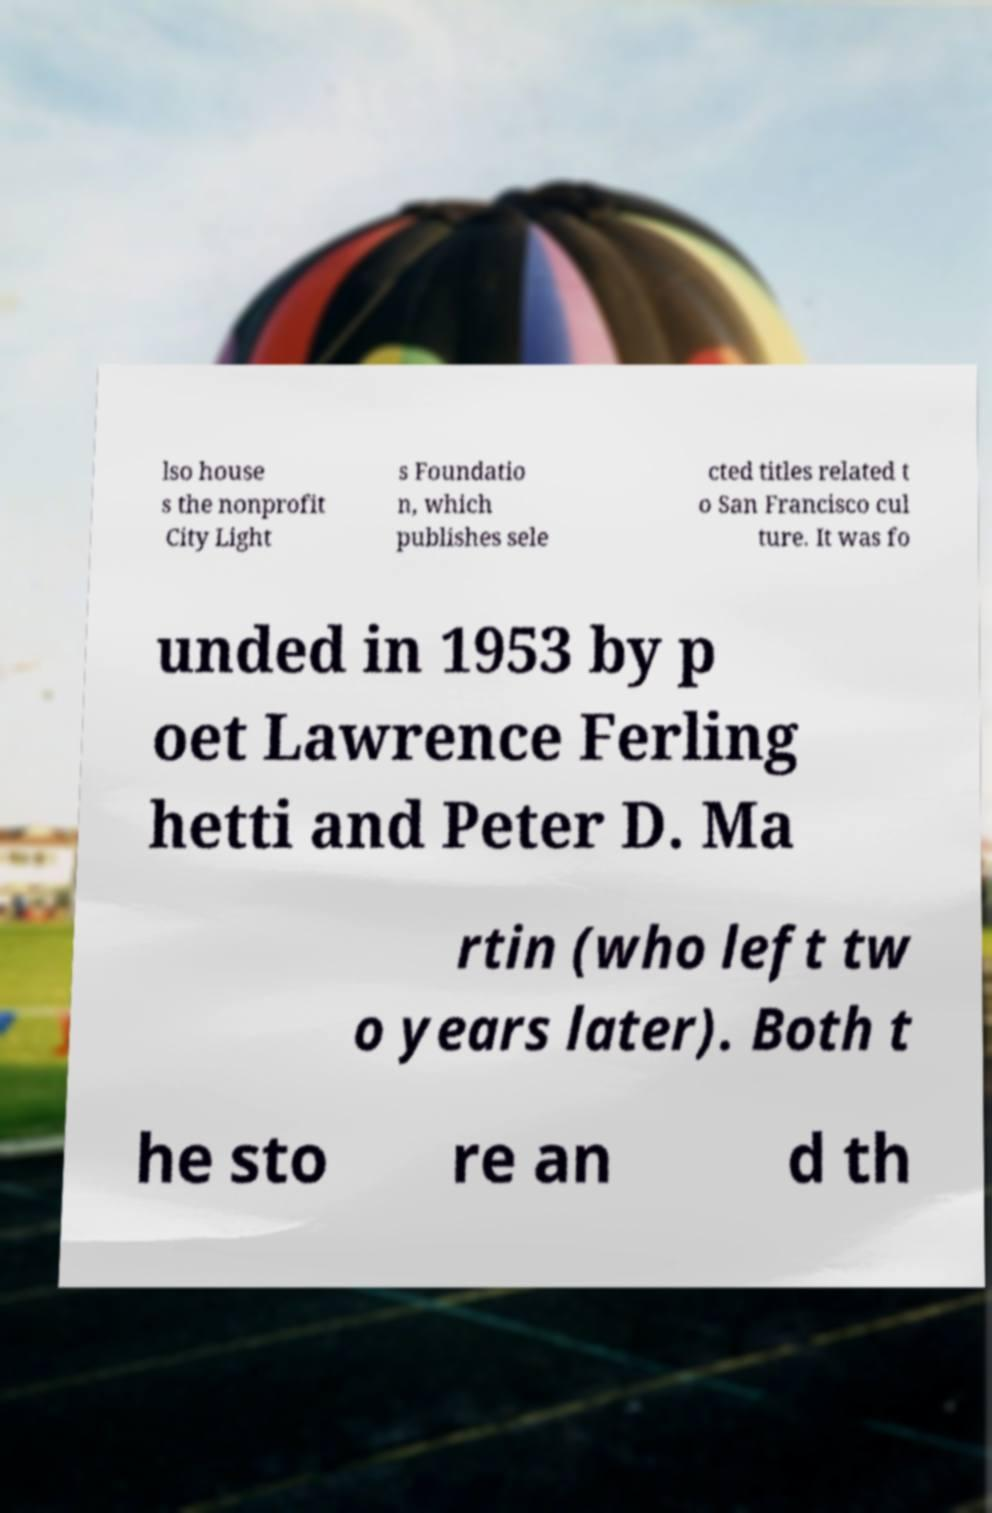Please identify and transcribe the text found in this image. lso house s the nonprofit City Light s Foundatio n, which publishes sele cted titles related t o San Francisco cul ture. It was fo unded in 1953 by p oet Lawrence Ferling hetti and Peter D. Ma rtin (who left tw o years later). Both t he sto re an d th 